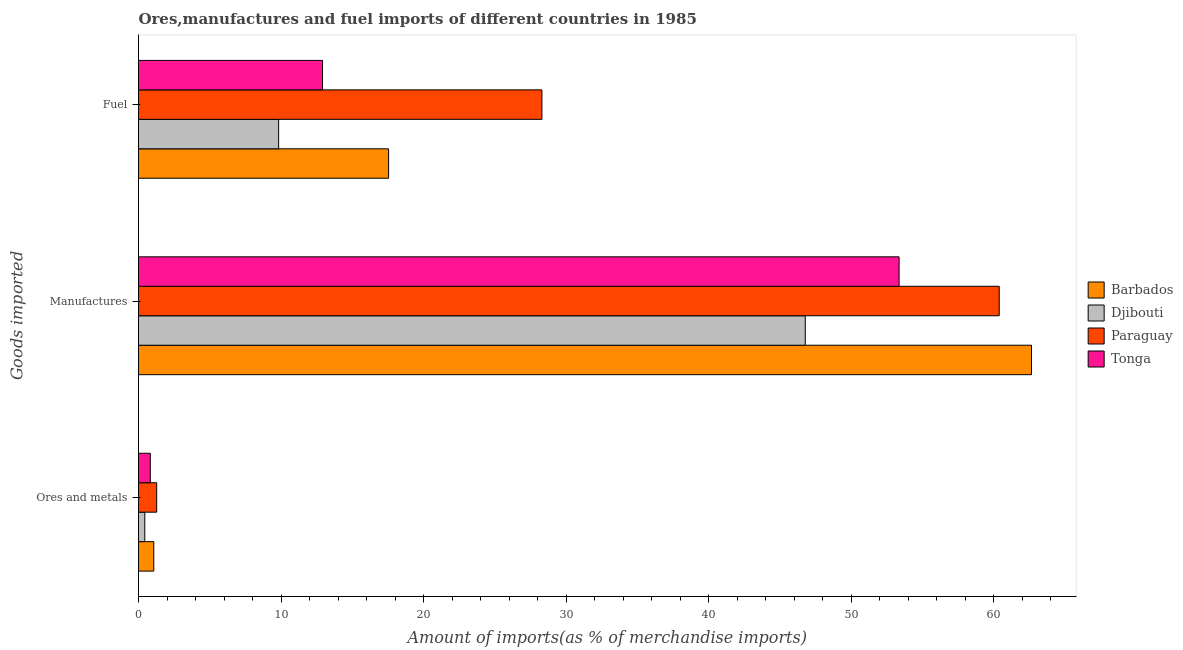How many groups of bars are there?
Provide a short and direct response. 3. Are the number of bars per tick equal to the number of legend labels?
Ensure brevity in your answer.  Yes. How many bars are there on the 1st tick from the top?
Ensure brevity in your answer.  4. What is the label of the 2nd group of bars from the top?
Offer a very short reply. Manufactures. What is the percentage of manufactures imports in Paraguay?
Offer a terse response. 60.39. Across all countries, what is the maximum percentage of manufactures imports?
Keep it short and to the point. 62.65. Across all countries, what is the minimum percentage of ores and metals imports?
Make the answer very short. 0.44. In which country was the percentage of manufactures imports maximum?
Provide a succinct answer. Barbados. In which country was the percentage of ores and metals imports minimum?
Your response must be concise. Djibouti. What is the total percentage of manufactures imports in the graph?
Provide a short and direct response. 223.18. What is the difference between the percentage of ores and metals imports in Paraguay and that in Barbados?
Your answer should be very brief. 0.2. What is the difference between the percentage of ores and metals imports in Paraguay and the percentage of manufactures imports in Barbados?
Your response must be concise. -61.38. What is the average percentage of ores and metals imports per country?
Your answer should be compact. 0.9. What is the difference between the percentage of ores and metals imports and percentage of manufactures imports in Djibouti?
Your answer should be very brief. -46.34. What is the ratio of the percentage of ores and metals imports in Djibouti to that in Tonga?
Offer a terse response. 0.53. What is the difference between the highest and the second highest percentage of ores and metals imports?
Offer a very short reply. 0.2. What is the difference between the highest and the lowest percentage of ores and metals imports?
Your response must be concise. 0.83. In how many countries, is the percentage of ores and metals imports greater than the average percentage of ores and metals imports taken over all countries?
Give a very brief answer. 2. Is the sum of the percentage of manufactures imports in Paraguay and Tonga greater than the maximum percentage of ores and metals imports across all countries?
Provide a short and direct response. Yes. What does the 1st bar from the top in Fuel represents?
Give a very brief answer. Tonga. What does the 4th bar from the bottom in Fuel represents?
Your answer should be compact. Tonga. Is it the case that in every country, the sum of the percentage of ores and metals imports and percentage of manufactures imports is greater than the percentage of fuel imports?
Provide a short and direct response. Yes. Are all the bars in the graph horizontal?
Keep it short and to the point. Yes. How many countries are there in the graph?
Give a very brief answer. 4. Are the values on the major ticks of X-axis written in scientific E-notation?
Offer a terse response. No. How many legend labels are there?
Make the answer very short. 4. How are the legend labels stacked?
Provide a short and direct response. Vertical. What is the title of the graph?
Ensure brevity in your answer.  Ores,manufactures and fuel imports of different countries in 1985. Does "Micronesia" appear as one of the legend labels in the graph?
Keep it short and to the point. No. What is the label or title of the X-axis?
Ensure brevity in your answer.  Amount of imports(as % of merchandise imports). What is the label or title of the Y-axis?
Offer a very short reply. Goods imported. What is the Amount of imports(as % of merchandise imports) of Barbados in Ores and metals?
Ensure brevity in your answer.  1.07. What is the Amount of imports(as % of merchandise imports) in Djibouti in Ores and metals?
Keep it short and to the point. 0.44. What is the Amount of imports(as % of merchandise imports) of Paraguay in Ores and metals?
Give a very brief answer. 1.27. What is the Amount of imports(as % of merchandise imports) in Tonga in Ores and metals?
Offer a very short reply. 0.83. What is the Amount of imports(as % of merchandise imports) of Barbados in Manufactures?
Your answer should be compact. 62.65. What is the Amount of imports(as % of merchandise imports) in Djibouti in Manufactures?
Make the answer very short. 46.78. What is the Amount of imports(as % of merchandise imports) in Paraguay in Manufactures?
Offer a terse response. 60.39. What is the Amount of imports(as % of merchandise imports) in Tonga in Manufactures?
Make the answer very short. 53.36. What is the Amount of imports(as % of merchandise imports) in Barbados in Fuel?
Provide a short and direct response. 17.55. What is the Amount of imports(as % of merchandise imports) of Djibouti in Fuel?
Ensure brevity in your answer.  9.83. What is the Amount of imports(as % of merchandise imports) of Paraguay in Fuel?
Offer a very short reply. 28.3. What is the Amount of imports(as % of merchandise imports) in Tonga in Fuel?
Your answer should be very brief. 12.91. Across all Goods imported, what is the maximum Amount of imports(as % of merchandise imports) in Barbados?
Give a very brief answer. 62.65. Across all Goods imported, what is the maximum Amount of imports(as % of merchandise imports) in Djibouti?
Make the answer very short. 46.78. Across all Goods imported, what is the maximum Amount of imports(as % of merchandise imports) in Paraguay?
Ensure brevity in your answer.  60.39. Across all Goods imported, what is the maximum Amount of imports(as % of merchandise imports) in Tonga?
Make the answer very short. 53.36. Across all Goods imported, what is the minimum Amount of imports(as % of merchandise imports) of Barbados?
Provide a short and direct response. 1.07. Across all Goods imported, what is the minimum Amount of imports(as % of merchandise imports) in Djibouti?
Ensure brevity in your answer.  0.44. Across all Goods imported, what is the minimum Amount of imports(as % of merchandise imports) in Paraguay?
Offer a very short reply. 1.27. Across all Goods imported, what is the minimum Amount of imports(as % of merchandise imports) of Tonga?
Give a very brief answer. 0.83. What is the total Amount of imports(as % of merchandise imports) in Barbados in the graph?
Give a very brief answer. 81.27. What is the total Amount of imports(as % of merchandise imports) in Djibouti in the graph?
Provide a short and direct response. 57.05. What is the total Amount of imports(as % of merchandise imports) of Paraguay in the graph?
Make the answer very short. 89.96. What is the total Amount of imports(as % of merchandise imports) in Tonga in the graph?
Keep it short and to the point. 67.1. What is the difference between the Amount of imports(as % of merchandise imports) in Barbados in Ores and metals and that in Manufactures?
Make the answer very short. -61.58. What is the difference between the Amount of imports(as % of merchandise imports) of Djibouti in Ores and metals and that in Manufactures?
Offer a terse response. -46.34. What is the difference between the Amount of imports(as % of merchandise imports) of Paraguay in Ores and metals and that in Manufactures?
Make the answer very short. -59.11. What is the difference between the Amount of imports(as % of merchandise imports) in Tonga in Ores and metals and that in Manufactures?
Provide a succinct answer. -52.53. What is the difference between the Amount of imports(as % of merchandise imports) of Barbados in Ores and metals and that in Fuel?
Your response must be concise. -16.47. What is the difference between the Amount of imports(as % of merchandise imports) of Djibouti in Ores and metals and that in Fuel?
Provide a short and direct response. -9.39. What is the difference between the Amount of imports(as % of merchandise imports) of Paraguay in Ores and metals and that in Fuel?
Offer a terse response. -27.03. What is the difference between the Amount of imports(as % of merchandise imports) of Tonga in Ores and metals and that in Fuel?
Offer a terse response. -12.08. What is the difference between the Amount of imports(as % of merchandise imports) of Barbados in Manufactures and that in Fuel?
Make the answer very short. 45.11. What is the difference between the Amount of imports(as % of merchandise imports) in Djibouti in Manufactures and that in Fuel?
Ensure brevity in your answer.  36.95. What is the difference between the Amount of imports(as % of merchandise imports) in Paraguay in Manufactures and that in Fuel?
Your answer should be compact. 32.08. What is the difference between the Amount of imports(as % of merchandise imports) of Tonga in Manufactures and that in Fuel?
Keep it short and to the point. 40.45. What is the difference between the Amount of imports(as % of merchandise imports) of Barbados in Ores and metals and the Amount of imports(as % of merchandise imports) of Djibouti in Manufactures?
Make the answer very short. -45.71. What is the difference between the Amount of imports(as % of merchandise imports) in Barbados in Ores and metals and the Amount of imports(as % of merchandise imports) in Paraguay in Manufactures?
Your response must be concise. -59.32. What is the difference between the Amount of imports(as % of merchandise imports) in Barbados in Ores and metals and the Amount of imports(as % of merchandise imports) in Tonga in Manufactures?
Your answer should be compact. -52.29. What is the difference between the Amount of imports(as % of merchandise imports) in Djibouti in Ores and metals and the Amount of imports(as % of merchandise imports) in Paraguay in Manufactures?
Provide a succinct answer. -59.95. What is the difference between the Amount of imports(as % of merchandise imports) of Djibouti in Ores and metals and the Amount of imports(as % of merchandise imports) of Tonga in Manufactures?
Your answer should be very brief. -52.92. What is the difference between the Amount of imports(as % of merchandise imports) in Paraguay in Ores and metals and the Amount of imports(as % of merchandise imports) in Tonga in Manufactures?
Provide a succinct answer. -52.09. What is the difference between the Amount of imports(as % of merchandise imports) in Barbados in Ores and metals and the Amount of imports(as % of merchandise imports) in Djibouti in Fuel?
Make the answer very short. -8.76. What is the difference between the Amount of imports(as % of merchandise imports) in Barbados in Ores and metals and the Amount of imports(as % of merchandise imports) in Paraguay in Fuel?
Keep it short and to the point. -27.23. What is the difference between the Amount of imports(as % of merchandise imports) of Barbados in Ores and metals and the Amount of imports(as % of merchandise imports) of Tonga in Fuel?
Your response must be concise. -11.84. What is the difference between the Amount of imports(as % of merchandise imports) in Djibouti in Ores and metals and the Amount of imports(as % of merchandise imports) in Paraguay in Fuel?
Provide a short and direct response. -27.86. What is the difference between the Amount of imports(as % of merchandise imports) in Djibouti in Ores and metals and the Amount of imports(as % of merchandise imports) in Tonga in Fuel?
Make the answer very short. -12.47. What is the difference between the Amount of imports(as % of merchandise imports) in Paraguay in Ores and metals and the Amount of imports(as % of merchandise imports) in Tonga in Fuel?
Your answer should be very brief. -11.64. What is the difference between the Amount of imports(as % of merchandise imports) in Barbados in Manufactures and the Amount of imports(as % of merchandise imports) in Djibouti in Fuel?
Ensure brevity in your answer.  52.82. What is the difference between the Amount of imports(as % of merchandise imports) in Barbados in Manufactures and the Amount of imports(as % of merchandise imports) in Paraguay in Fuel?
Offer a terse response. 34.35. What is the difference between the Amount of imports(as % of merchandise imports) of Barbados in Manufactures and the Amount of imports(as % of merchandise imports) of Tonga in Fuel?
Provide a short and direct response. 49.74. What is the difference between the Amount of imports(as % of merchandise imports) in Djibouti in Manufactures and the Amount of imports(as % of merchandise imports) in Paraguay in Fuel?
Your answer should be very brief. 18.48. What is the difference between the Amount of imports(as % of merchandise imports) in Djibouti in Manufactures and the Amount of imports(as % of merchandise imports) in Tonga in Fuel?
Make the answer very short. 33.87. What is the difference between the Amount of imports(as % of merchandise imports) of Paraguay in Manufactures and the Amount of imports(as % of merchandise imports) of Tonga in Fuel?
Your answer should be compact. 47.48. What is the average Amount of imports(as % of merchandise imports) of Barbados per Goods imported?
Offer a very short reply. 27.09. What is the average Amount of imports(as % of merchandise imports) in Djibouti per Goods imported?
Offer a terse response. 19.02. What is the average Amount of imports(as % of merchandise imports) of Paraguay per Goods imported?
Offer a terse response. 29.99. What is the average Amount of imports(as % of merchandise imports) of Tonga per Goods imported?
Your answer should be compact. 22.37. What is the difference between the Amount of imports(as % of merchandise imports) in Barbados and Amount of imports(as % of merchandise imports) in Djibouti in Ores and metals?
Your answer should be very brief. 0.63. What is the difference between the Amount of imports(as % of merchandise imports) in Barbados and Amount of imports(as % of merchandise imports) in Paraguay in Ores and metals?
Make the answer very short. -0.2. What is the difference between the Amount of imports(as % of merchandise imports) in Barbados and Amount of imports(as % of merchandise imports) in Tonga in Ores and metals?
Offer a very short reply. 0.24. What is the difference between the Amount of imports(as % of merchandise imports) of Djibouti and Amount of imports(as % of merchandise imports) of Paraguay in Ores and metals?
Keep it short and to the point. -0.83. What is the difference between the Amount of imports(as % of merchandise imports) in Djibouti and Amount of imports(as % of merchandise imports) in Tonga in Ores and metals?
Provide a succinct answer. -0.39. What is the difference between the Amount of imports(as % of merchandise imports) in Paraguay and Amount of imports(as % of merchandise imports) in Tonga in Ores and metals?
Provide a short and direct response. 0.45. What is the difference between the Amount of imports(as % of merchandise imports) in Barbados and Amount of imports(as % of merchandise imports) in Djibouti in Manufactures?
Keep it short and to the point. 15.87. What is the difference between the Amount of imports(as % of merchandise imports) of Barbados and Amount of imports(as % of merchandise imports) of Paraguay in Manufactures?
Offer a very short reply. 2.27. What is the difference between the Amount of imports(as % of merchandise imports) in Barbados and Amount of imports(as % of merchandise imports) in Tonga in Manufactures?
Offer a very short reply. 9.29. What is the difference between the Amount of imports(as % of merchandise imports) of Djibouti and Amount of imports(as % of merchandise imports) of Paraguay in Manufactures?
Keep it short and to the point. -13.61. What is the difference between the Amount of imports(as % of merchandise imports) in Djibouti and Amount of imports(as % of merchandise imports) in Tonga in Manufactures?
Ensure brevity in your answer.  -6.58. What is the difference between the Amount of imports(as % of merchandise imports) of Paraguay and Amount of imports(as % of merchandise imports) of Tonga in Manufactures?
Your answer should be compact. 7.02. What is the difference between the Amount of imports(as % of merchandise imports) in Barbados and Amount of imports(as % of merchandise imports) in Djibouti in Fuel?
Your response must be concise. 7.71. What is the difference between the Amount of imports(as % of merchandise imports) of Barbados and Amount of imports(as % of merchandise imports) of Paraguay in Fuel?
Make the answer very short. -10.76. What is the difference between the Amount of imports(as % of merchandise imports) of Barbados and Amount of imports(as % of merchandise imports) of Tonga in Fuel?
Ensure brevity in your answer.  4.64. What is the difference between the Amount of imports(as % of merchandise imports) of Djibouti and Amount of imports(as % of merchandise imports) of Paraguay in Fuel?
Your answer should be compact. -18.47. What is the difference between the Amount of imports(as % of merchandise imports) of Djibouti and Amount of imports(as % of merchandise imports) of Tonga in Fuel?
Give a very brief answer. -3.08. What is the difference between the Amount of imports(as % of merchandise imports) of Paraguay and Amount of imports(as % of merchandise imports) of Tonga in Fuel?
Keep it short and to the point. 15.39. What is the ratio of the Amount of imports(as % of merchandise imports) in Barbados in Ores and metals to that in Manufactures?
Your response must be concise. 0.02. What is the ratio of the Amount of imports(as % of merchandise imports) in Djibouti in Ores and metals to that in Manufactures?
Your response must be concise. 0.01. What is the ratio of the Amount of imports(as % of merchandise imports) of Paraguay in Ores and metals to that in Manufactures?
Keep it short and to the point. 0.02. What is the ratio of the Amount of imports(as % of merchandise imports) in Tonga in Ores and metals to that in Manufactures?
Keep it short and to the point. 0.02. What is the ratio of the Amount of imports(as % of merchandise imports) in Barbados in Ores and metals to that in Fuel?
Your answer should be compact. 0.06. What is the ratio of the Amount of imports(as % of merchandise imports) of Djibouti in Ores and metals to that in Fuel?
Provide a short and direct response. 0.04. What is the ratio of the Amount of imports(as % of merchandise imports) of Paraguay in Ores and metals to that in Fuel?
Make the answer very short. 0.04. What is the ratio of the Amount of imports(as % of merchandise imports) of Tonga in Ores and metals to that in Fuel?
Your answer should be very brief. 0.06. What is the ratio of the Amount of imports(as % of merchandise imports) in Barbados in Manufactures to that in Fuel?
Offer a very short reply. 3.57. What is the ratio of the Amount of imports(as % of merchandise imports) in Djibouti in Manufactures to that in Fuel?
Keep it short and to the point. 4.76. What is the ratio of the Amount of imports(as % of merchandise imports) in Paraguay in Manufactures to that in Fuel?
Offer a very short reply. 2.13. What is the ratio of the Amount of imports(as % of merchandise imports) of Tonga in Manufactures to that in Fuel?
Provide a short and direct response. 4.13. What is the difference between the highest and the second highest Amount of imports(as % of merchandise imports) of Barbados?
Your answer should be compact. 45.11. What is the difference between the highest and the second highest Amount of imports(as % of merchandise imports) of Djibouti?
Provide a succinct answer. 36.95. What is the difference between the highest and the second highest Amount of imports(as % of merchandise imports) in Paraguay?
Your response must be concise. 32.08. What is the difference between the highest and the second highest Amount of imports(as % of merchandise imports) in Tonga?
Offer a very short reply. 40.45. What is the difference between the highest and the lowest Amount of imports(as % of merchandise imports) in Barbados?
Your answer should be compact. 61.58. What is the difference between the highest and the lowest Amount of imports(as % of merchandise imports) in Djibouti?
Your answer should be compact. 46.34. What is the difference between the highest and the lowest Amount of imports(as % of merchandise imports) in Paraguay?
Your answer should be compact. 59.11. What is the difference between the highest and the lowest Amount of imports(as % of merchandise imports) in Tonga?
Give a very brief answer. 52.53. 